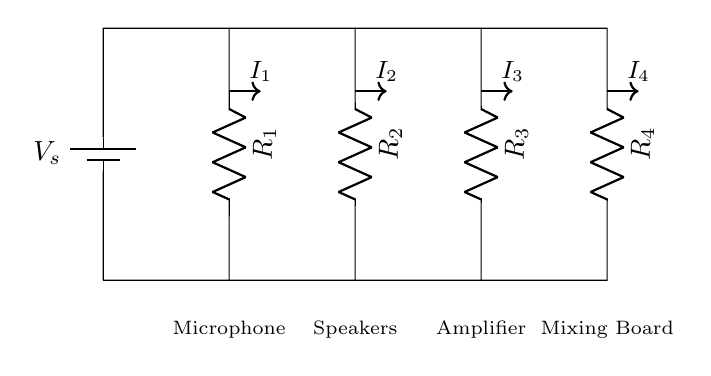What are the components in this circuit? The circuit contains a voltage source and four resistors, which are represented by specific symbols. The resistors are labeled R1, R2, R3, and R4.
Answer: voltage source, R1, R2, R3, R4 What type of circuit is depicted here? The circuit is a parallel circuit because multiple components (resistors in this case) are connected across the same two terminals, allowing multiple current paths.
Answer: parallel circuit What is the purpose of the current divider in this circuit? The current divider distributes the total current from the voltage source to each resistor in proportion to their resistance values, allowing the audio equipment to function correctly.
Answer: distribute current How many paths for the current are present? There are four distinct paths for the current in this circuit, one for each resistor parallel to the voltage source.
Answer: four Which audio equipment is connected to R2? The equipment connected to R2 is the speakers, as indicated by the label below the resistor in the diagram.
Answer: Speakers What does the current I2 represent in this circuit? The current I2 represents the current flowing through resistor R2, which is assigned to the speakers. The value of I2 can be calculated using the current divider rule.
Answer: Current through R2 How does changing R1 affect the current distribution among resistors? Changing R1 alters the total resistance of the circuit, affecting the voltage drop across and thus the current through R1, which also influences the remaining current distribution among other resistors due to the parallel configuration.
Answer: Affects current distribution 